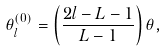Convert formula to latex. <formula><loc_0><loc_0><loc_500><loc_500>\theta _ { l } ^ { ( 0 ) } = \left ( \frac { 2 l - L - 1 } { L - 1 } \right ) \theta ,</formula> 